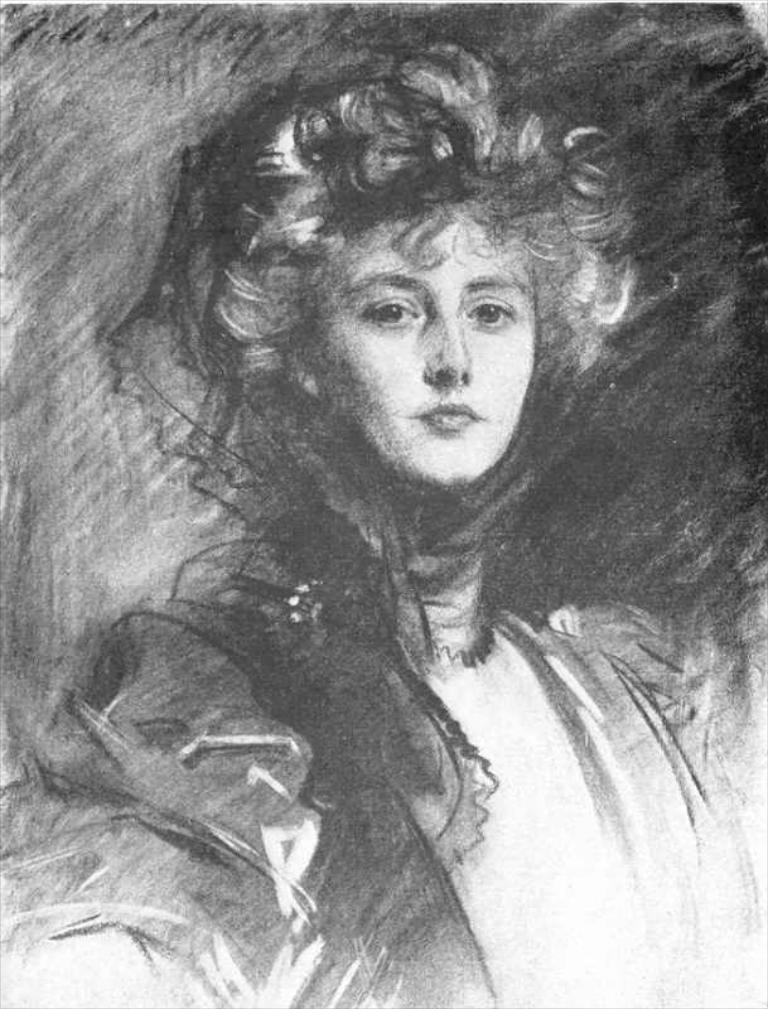What is depicted in the image? There is a drawing of a woman in the image. What type of drug is the woman using in the image? There is no drug present in the image; it is a drawing of a woman. What is the woman's role in the army in the image? There is no army or indication of a specific role in the image; it is a drawing of a woman. 